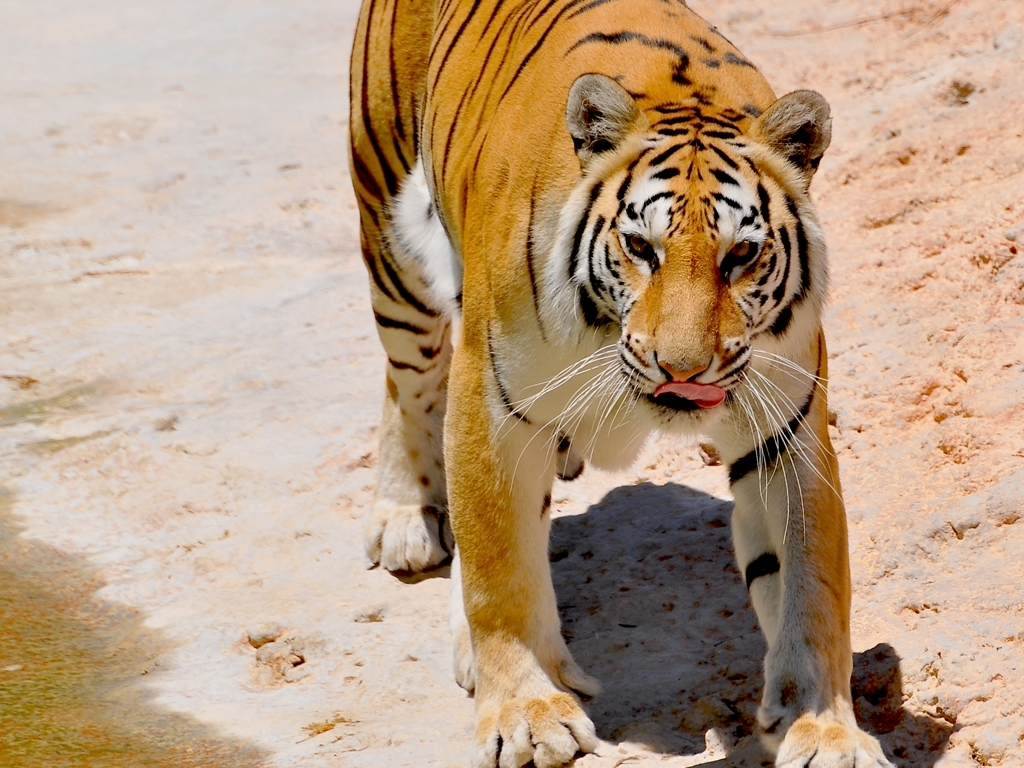Is the overall clarity excellent? The image is quite clear with sharp details allowing for a good view of the tiger's texture, patterns, and facial expressions. The focus is well-maintained on the subject, providing an excellent representation of its features. 